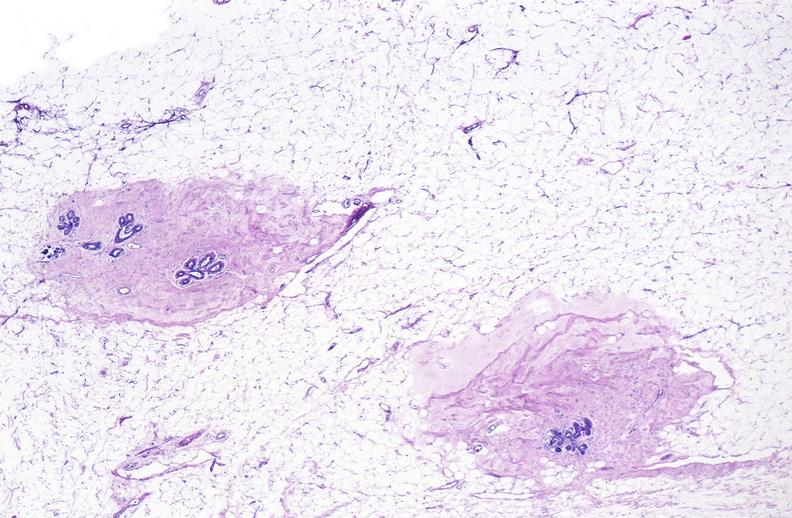does this image show normal breast?
Answer the question using a single word or phrase. Yes 